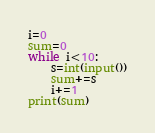<code> <loc_0><loc_0><loc_500><loc_500><_Python_>i=0
sum=0
while i<10:
    s=int(input())
    sum+=s
    i+=1
print(sum)
</code> 